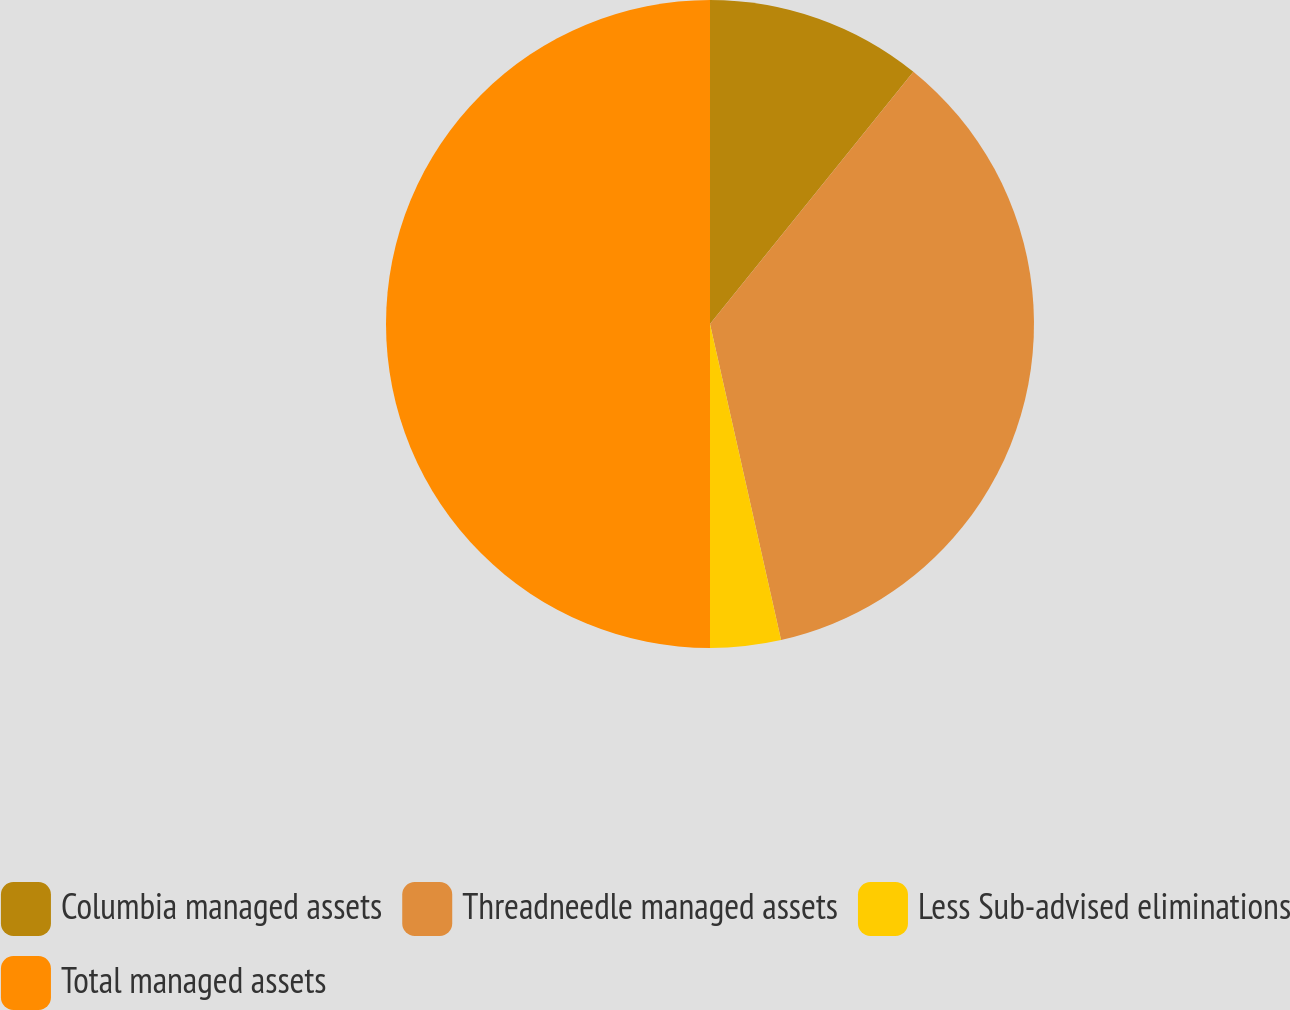Convert chart to OTSL. <chart><loc_0><loc_0><loc_500><loc_500><pie_chart><fcel>Columbia managed assets<fcel>Threadneedle managed assets<fcel>Less Sub-advised eliminations<fcel>Total managed assets<nl><fcel>10.8%<fcel>35.68%<fcel>3.52%<fcel>50.0%<nl></chart> 